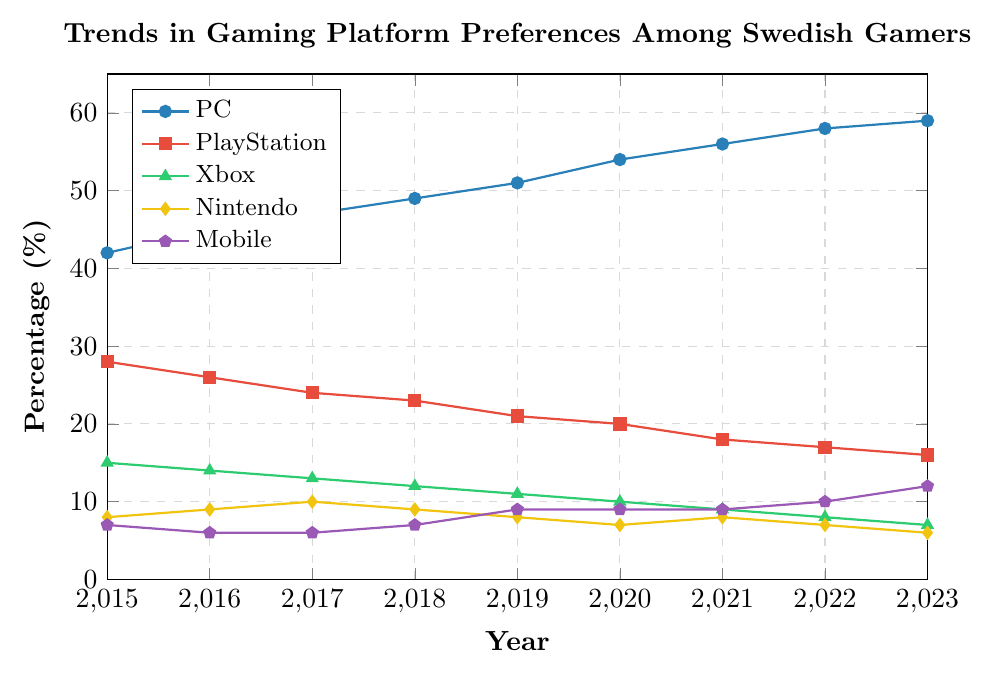What's the dominant gaming platform among Swedish gamers in 2023? Looking at the plot for the year 2023 and comparing the values, PC is the highest with 59%.
Answer: PC How did the percentage of Mobile gamers change from 2015 to 2023? The Mobile segment in 2015 was at 7%, and in 2023 it's at 12%. The change is calculated by subtracting the earlier value from the later value: 12% - 7% = 5%.
Answer: +5% Which gaming platform showed a continuous increase in its preference percentage over the years? Observing the trend lines for each platform from 2015 to 2023, only the PC shows a continuous increase reaching from 42% to 59%.
Answer: PC By how much did the preference for Xbox decline from 2015 to 2023? The Xbox preference in 2015 was 15%, and in 2023 it is 7%. The decline can be calculated as 15% - 7% = 8%.
Answer: 8% Which two gaming platforms had the same percentage preference in any given year? Observing the chart, in 2020 both Nintendo and Mobile had the same preference percentage of 9%.
Answer: Nintendo and Mobile in 2020 What is the average percentage preference for PlayStation over the years 2015 to 2023? Adding the values from 2015 to 2023 (28, 26, 24, 23, 21, 20, 18, 17, 16) yields a sum of 193. Dividing by the number of years (9) gives 193 / 9 ≈ 21.44%.
Answer: 21.44% In which year did the Mobile gaming platform see the highest increase in preference compared to the previous year? Observing the Mobile trend line, from 2022 to 2023 the percentage increased from 10% to 12%, which is a 2% increase, the highest observed.
Answer: 2023 Which platform exhibited the most stable trend (least fluctuation) over the years? By comparing year-on-year fluctuations for all platforms, the Mobile gaming platform shows the least dramatic year-on-year changes, generally moving steadily with small changes.
Answer: Mobile Compare the trend of PC and PlayStation preferences between 2015 and 2023. PC preference increased from 42% to 59% showing a consistent upward trend, while PlayStation decreased from 28% to 16%, showing a consistent downward trend.
Answer: PC increased, PlayStation decreased What is the total percentage change for Nintendo from 2015 to 2023? The percentage for Nintendo in 2015 was 8%, and in 2023 it is 6%. The total percentage change is calculated as 6% - 8% = -2%.
Answer: -2% 